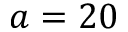<formula> <loc_0><loc_0><loc_500><loc_500>a = 2 0</formula> 